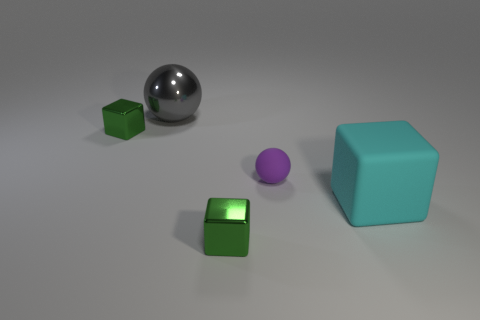What is the size of the purple ball that is the same material as the large cube?
Give a very brief answer. Small. What number of green things are either balls or matte spheres?
Provide a short and direct response. 0. How many gray metallic balls are behind the small metal block that is behind the small purple matte ball?
Your answer should be very brief. 1. Is the number of cubes that are in front of the rubber ball greater than the number of matte blocks to the right of the large block?
Offer a very short reply. Yes. What is the cyan object made of?
Offer a terse response. Rubber. Is there a yellow metallic thing that has the same size as the purple matte ball?
Offer a very short reply. No. There is another thing that is the same size as the gray shiny thing; what material is it?
Your answer should be compact. Rubber. How many small brown metallic cylinders are there?
Provide a succinct answer. 0. How big is the thing right of the tiny purple thing?
Your response must be concise. Large. Is the number of small green cubes in front of the big cyan matte cube the same as the number of rubber cubes?
Your answer should be very brief. Yes. 